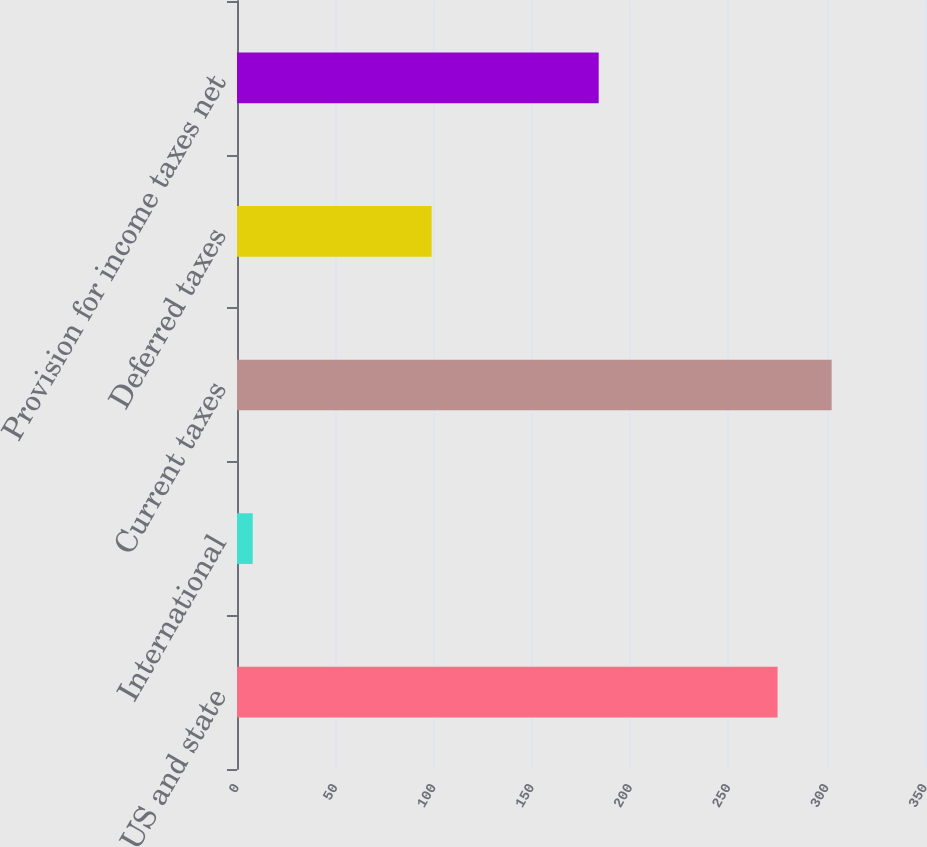<chart> <loc_0><loc_0><loc_500><loc_500><bar_chart><fcel>US and state<fcel>International<fcel>Current taxes<fcel>Deferred taxes<fcel>Provision for income taxes net<nl><fcel>275<fcel>8<fcel>302.5<fcel>99<fcel>184<nl></chart> 